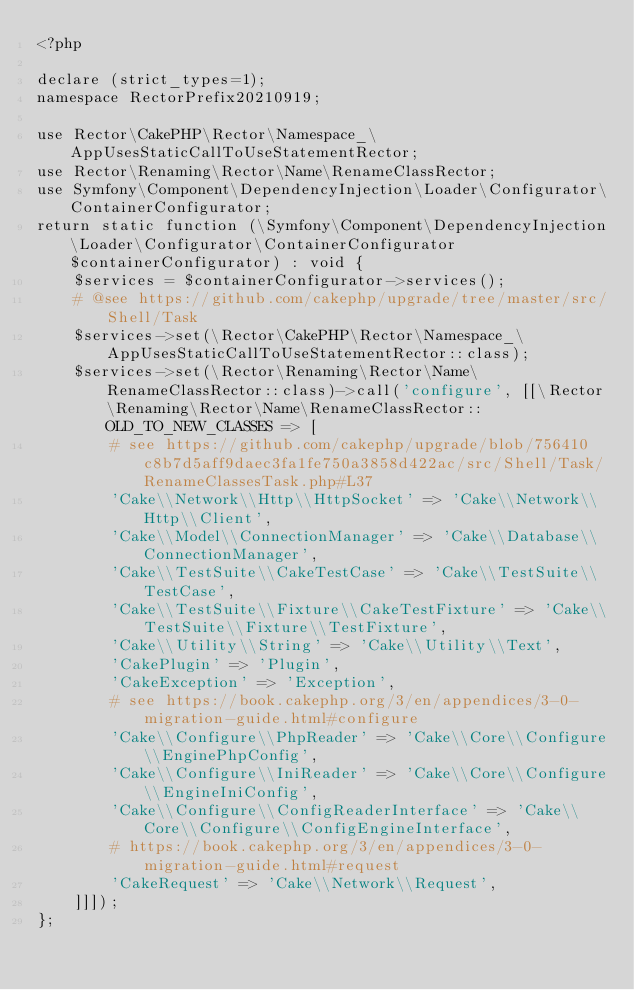<code> <loc_0><loc_0><loc_500><loc_500><_PHP_><?php

declare (strict_types=1);
namespace RectorPrefix20210919;

use Rector\CakePHP\Rector\Namespace_\AppUsesStaticCallToUseStatementRector;
use Rector\Renaming\Rector\Name\RenameClassRector;
use Symfony\Component\DependencyInjection\Loader\Configurator\ContainerConfigurator;
return static function (\Symfony\Component\DependencyInjection\Loader\Configurator\ContainerConfigurator $containerConfigurator) : void {
    $services = $containerConfigurator->services();
    # @see https://github.com/cakephp/upgrade/tree/master/src/Shell/Task
    $services->set(\Rector\CakePHP\Rector\Namespace_\AppUsesStaticCallToUseStatementRector::class);
    $services->set(\Rector\Renaming\Rector\Name\RenameClassRector::class)->call('configure', [[\Rector\Renaming\Rector\Name\RenameClassRector::OLD_TO_NEW_CLASSES => [
        # see https://github.com/cakephp/upgrade/blob/756410c8b7d5aff9daec3fa1fe750a3858d422ac/src/Shell/Task/RenameClassesTask.php#L37
        'Cake\\Network\\Http\\HttpSocket' => 'Cake\\Network\\Http\\Client',
        'Cake\\Model\\ConnectionManager' => 'Cake\\Database\\ConnectionManager',
        'Cake\\TestSuite\\CakeTestCase' => 'Cake\\TestSuite\\TestCase',
        'Cake\\TestSuite\\Fixture\\CakeTestFixture' => 'Cake\\TestSuite\\Fixture\\TestFixture',
        'Cake\\Utility\\String' => 'Cake\\Utility\\Text',
        'CakePlugin' => 'Plugin',
        'CakeException' => 'Exception',
        # see https://book.cakephp.org/3/en/appendices/3-0-migration-guide.html#configure
        'Cake\\Configure\\PhpReader' => 'Cake\\Core\\Configure\\EnginePhpConfig',
        'Cake\\Configure\\IniReader' => 'Cake\\Core\\Configure\\EngineIniConfig',
        'Cake\\Configure\\ConfigReaderInterface' => 'Cake\\Core\\Configure\\ConfigEngineInterface',
        # https://book.cakephp.org/3/en/appendices/3-0-migration-guide.html#request
        'CakeRequest' => 'Cake\\Network\\Request',
    ]]]);
};
</code> 